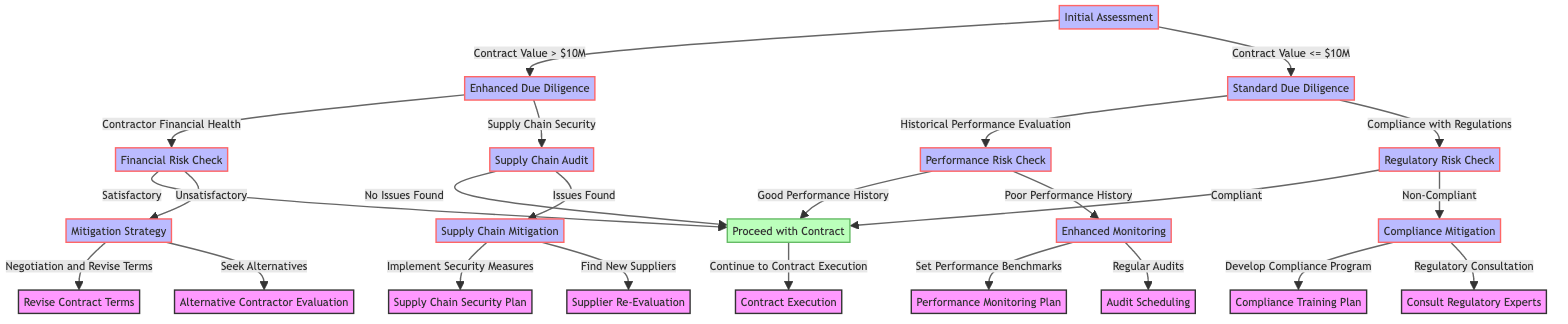What happens after an Initial Assessment if the Contract Value is greater than $10M? If the Contract Value is greater than $10M, the next node after the Initial Assessment is Enhanced Due Diligence.
Answer: Enhanced Due Diligence What is the next step if Supply Chain Security is a concern during Enhanced Due Diligence? If Supply Chain Security is a concern during Enhanced Due Diligence, the next step is a Supply Chain Audit.
Answer: Supply Chain Audit How many options lead to the node Proceed with Contract? There are four options that lead to the Proceed with Contract node: Satisfactory Financial Risk Check, No Issues Found in Supply Chain Audit, Good Performance History, and Compliant in Regulatory Risk Check.
Answer: Four What is the outcome if the Financial Risk Check is Unsatisfactory? If the Financial Risk Check is Unsatisfactory, the next node is Mitigation Strategy.
Answer: Mitigation Strategy What can follow if a contractor has Poor Performance History? If a contractor has Poor Performance History, the next step would be Enhanced Monitoring.
Answer: Enhanced Monitoring What is the next action if issues are found in the Supply Chain Audit? If issues are found in the Supply Chain Audit, the next step is Supply Chain Mitigation.
Answer: Supply Chain Mitigation What are the two options available if the Regulatory Risk Check reveals non-compliance? If the Regulatory Risk Check reveals non-compliance, the two options are to Develop Compliance Program and Regulatory Consultation.
Answer: Develop Compliance Program, Regulatory Consultation What would happen next if the Performance Risk Check results in Good Performance History? If the Performance Risk Check results in Good Performance History, the next step is to Proceed with Contract.
Answer: Proceed with Contract What does a transition from Initial Assessment to Standard Due Diligence indicate? A transition from Initial Assessment to Standard Due Diligence indicates that the Contract Value is less than or equal to $10M.
Answer: Contract Value <= $10M 